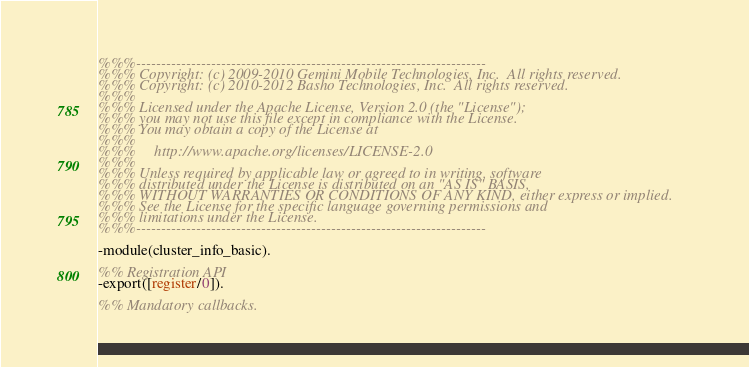<code> <loc_0><loc_0><loc_500><loc_500><_Erlang_>%%%----------------------------------------------------------------------
%%% Copyright: (c) 2009-2010 Gemini Mobile Technologies, Inc.  All rights reserved.
%%% Copyright: (c) 2010-2012 Basho Technologies, Inc.  All rights reserved.
%%%
%%% Licensed under the Apache License, Version 2.0 (the "License");
%%% you may not use this file except in compliance with the License.
%%% You may obtain a copy of the License at
%%%
%%%     http://www.apache.org/licenses/LICENSE-2.0
%%%
%%% Unless required by applicable law or agreed to in writing, software
%%% distributed under the License is distributed on an "AS IS" BASIS,
%%% WITHOUT WARRANTIES OR CONDITIONS OF ANY KIND, either express or implied.
%%% See the License for the specific language governing permissions and
%%% limitations under the License.
%%%----------------------------------------------------------------------

-module(cluster_info_basic).

%% Registration API
-export([register/0]).

%% Mandatory callbacks.</code> 